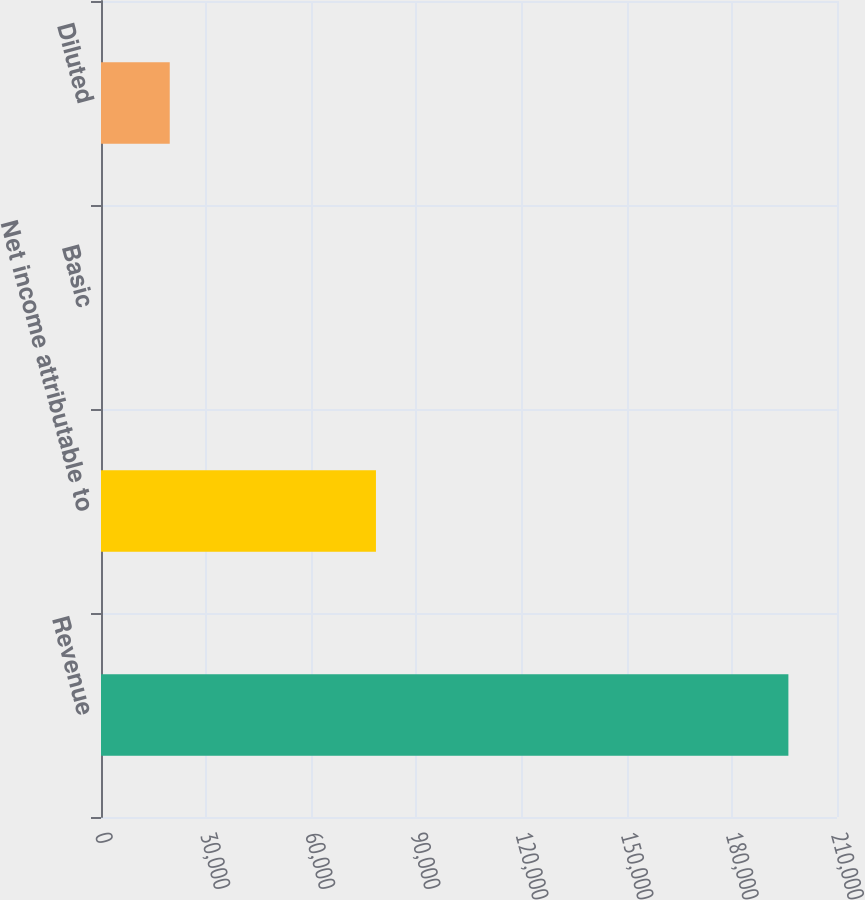<chart> <loc_0><loc_0><loc_500><loc_500><bar_chart><fcel>Revenue<fcel>Net income attributable to<fcel>Basic<fcel>Diluted<nl><fcel>196131<fcel>78452.5<fcel>0.26<fcel>19613.3<nl></chart> 